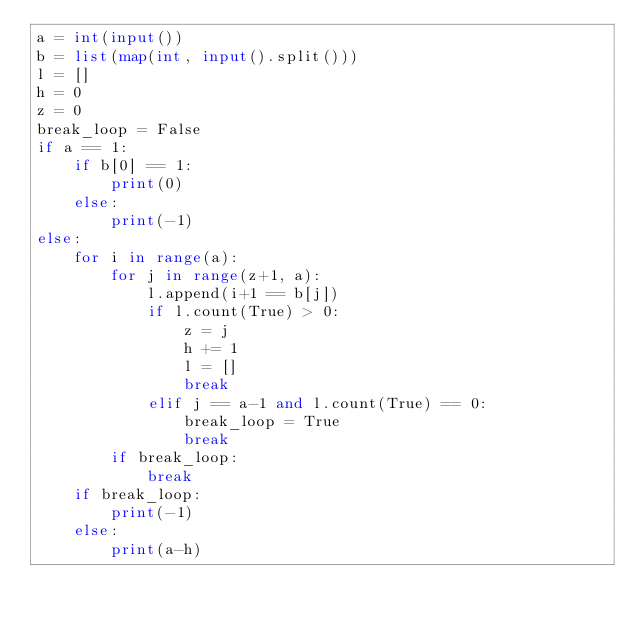Convert code to text. <code><loc_0><loc_0><loc_500><loc_500><_Python_>a = int(input())
b = list(map(int, input().split()))
l = []
h = 0
z = 0
break_loop = False
if a == 1:
    if b[0] == 1:
        print(0)
    else:
        print(-1)
else:
    for i in range(a):
        for j in range(z+1, a):
            l.append(i+1 == b[j])
            if l.count(True) > 0:
                z = j
                h += 1
                l = []
                break
            elif j == a-1 and l.count(True) == 0:
                break_loop = True
                break
        if break_loop:
            break
    if break_loop:
        print(-1)
    else:
        print(a-h)</code> 